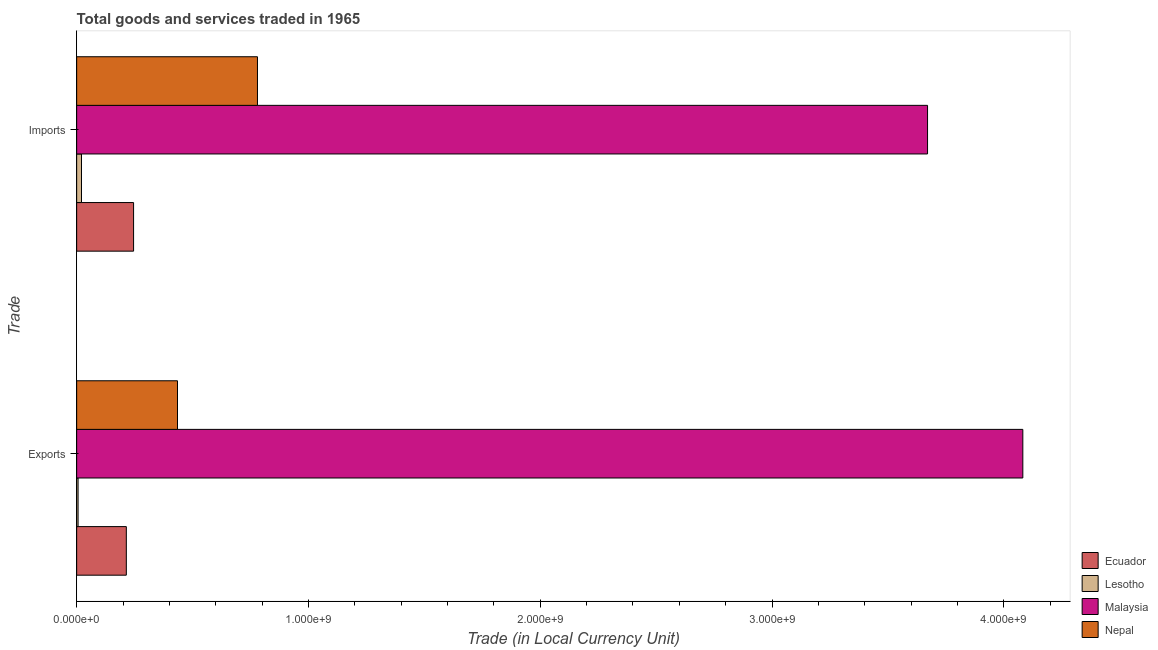How many different coloured bars are there?
Your answer should be very brief. 4. What is the label of the 1st group of bars from the top?
Offer a terse response. Imports. What is the imports of goods and services in Malaysia?
Offer a terse response. 3.67e+09. Across all countries, what is the maximum export of goods and services?
Offer a very short reply. 4.08e+09. Across all countries, what is the minimum export of goods and services?
Your response must be concise. 6.10e+06. In which country was the export of goods and services maximum?
Offer a very short reply. Malaysia. In which country was the export of goods and services minimum?
Provide a succinct answer. Lesotho. What is the total imports of goods and services in the graph?
Your answer should be very brief. 4.72e+09. What is the difference between the imports of goods and services in Malaysia and that in Lesotho?
Your answer should be compact. 3.65e+09. What is the difference between the imports of goods and services in Lesotho and the export of goods and services in Nepal?
Offer a terse response. -4.14e+08. What is the average imports of goods and services per country?
Keep it short and to the point. 1.18e+09. What is the difference between the export of goods and services and imports of goods and services in Nepal?
Give a very brief answer. -3.45e+08. In how many countries, is the imports of goods and services greater than 3800000000 LCU?
Make the answer very short. 0. What is the ratio of the export of goods and services in Nepal to that in Ecuador?
Ensure brevity in your answer.  2.03. Is the export of goods and services in Lesotho less than that in Ecuador?
Keep it short and to the point. Yes. What does the 4th bar from the top in Exports represents?
Offer a very short reply. Ecuador. What does the 1st bar from the bottom in Imports represents?
Offer a very short reply. Ecuador. How many bars are there?
Offer a terse response. 8. How many countries are there in the graph?
Keep it short and to the point. 4. What is the difference between two consecutive major ticks on the X-axis?
Provide a succinct answer. 1.00e+09. Are the values on the major ticks of X-axis written in scientific E-notation?
Offer a very short reply. Yes. Where does the legend appear in the graph?
Provide a succinct answer. Bottom right. How are the legend labels stacked?
Provide a short and direct response. Vertical. What is the title of the graph?
Your answer should be compact. Total goods and services traded in 1965. Does "Cayman Islands" appear as one of the legend labels in the graph?
Provide a succinct answer. No. What is the label or title of the X-axis?
Provide a short and direct response. Trade (in Local Currency Unit). What is the label or title of the Y-axis?
Your answer should be very brief. Trade. What is the Trade (in Local Currency Unit) in Ecuador in Exports?
Ensure brevity in your answer.  2.14e+08. What is the Trade (in Local Currency Unit) of Lesotho in Exports?
Make the answer very short. 6.10e+06. What is the Trade (in Local Currency Unit) in Malaysia in Exports?
Your response must be concise. 4.08e+09. What is the Trade (in Local Currency Unit) of Nepal in Exports?
Your answer should be compact. 4.35e+08. What is the Trade (in Local Currency Unit) of Ecuador in Imports?
Give a very brief answer. 2.46e+08. What is the Trade (in Local Currency Unit) in Lesotho in Imports?
Your answer should be very brief. 2.09e+07. What is the Trade (in Local Currency Unit) of Malaysia in Imports?
Offer a very short reply. 3.67e+09. What is the Trade (in Local Currency Unit) in Nepal in Imports?
Make the answer very short. 7.80e+08. Across all Trade, what is the maximum Trade (in Local Currency Unit) of Ecuador?
Make the answer very short. 2.46e+08. Across all Trade, what is the maximum Trade (in Local Currency Unit) of Lesotho?
Give a very brief answer. 2.09e+07. Across all Trade, what is the maximum Trade (in Local Currency Unit) in Malaysia?
Provide a succinct answer. 4.08e+09. Across all Trade, what is the maximum Trade (in Local Currency Unit) in Nepal?
Offer a terse response. 7.80e+08. Across all Trade, what is the minimum Trade (in Local Currency Unit) in Ecuador?
Provide a succinct answer. 2.14e+08. Across all Trade, what is the minimum Trade (in Local Currency Unit) in Lesotho?
Ensure brevity in your answer.  6.10e+06. Across all Trade, what is the minimum Trade (in Local Currency Unit) of Malaysia?
Your answer should be very brief. 3.67e+09. Across all Trade, what is the minimum Trade (in Local Currency Unit) in Nepal?
Provide a succinct answer. 4.35e+08. What is the total Trade (in Local Currency Unit) of Ecuador in the graph?
Ensure brevity in your answer.  4.60e+08. What is the total Trade (in Local Currency Unit) of Lesotho in the graph?
Offer a terse response. 2.70e+07. What is the total Trade (in Local Currency Unit) in Malaysia in the graph?
Provide a succinct answer. 7.75e+09. What is the total Trade (in Local Currency Unit) in Nepal in the graph?
Offer a very short reply. 1.22e+09. What is the difference between the Trade (in Local Currency Unit) in Ecuador in Exports and that in Imports?
Provide a succinct answer. -3.13e+07. What is the difference between the Trade (in Local Currency Unit) in Lesotho in Exports and that in Imports?
Offer a very short reply. -1.48e+07. What is the difference between the Trade (in Local Currency Unit) of Malaysia in Exports and that in Imports?
Offer a terse response. 4.11e+08. What is the difference between the Trade (in Local Currency Unit) of Nepal in Exports and that in Imports?
Give a very brief answer. -3.45e+08. What is the difference between the Trade (in Local Currency Unit) in Ecuador in Exports and the Trade (in Local Currency Unit) in Lesotho in Imports?
Make the answer very short. 1.93e+08. What is the difference between the Trade (in Local Currency Unit) in Ecuador in Exports and the Trade (in Local Currency Unit) in Malaysia in Imports?
Provide a succinct answer. -3.46e+09. What is the difference between the Trade (in Local Currency Unit) in Ecuador in Exports and the Trade (in Local Currency Unit) in Nepal in Imports?
Your response must be concise. -5.66e+08. What is the difference between the Trade (in Local Currency Unit) of Lesotho in Exports and the Trade (in Local Currency Unit) of Malaysia in Imports?
Offer a very short reply. -3.66e+09. What is the difference between the Trade (in Local Currency Unit) of Lesotho in Exports and the Trade (in Local Currency Unit) of Nepal in Imports?
Provide a short and direct response. -7.74e+08. What is the difference between the Trade (in Local Currency Unit) in Malaysia in Exports and the Trade (in Local Currency Unit) in Nepal in Imports?
Provide a short and direct response. 3.30e+09. What is the average Trade (in Local Currency Unit) of Ecuador per Trade?
Your answer should be compact. 2.30e+08. What is the average Trade (in Local Currency Unit) in Lesotho per Trade?
Your response must be concise. 1.35e+07. What is the average Trade (in Local Currency Unit) in Malaysia per Trade?
Keep it short and to the point. 3.88e+09. What is the average Trade (in Local Currency Unit) in Nepal per Trade?
Give a very brief answer. 6.08e+08. What is the difference between the Trade (in Local Currency Unit) of Ecuador and Trade (in Local Currency Unit) of Lesotho in Exports?
Your response must be concise. 2.08e+08. What is the difference between the Trade (in Local Currency Unit) of Ecuador and Trade (in Local Currency Unit) of Malaysia in Exports?
Your answer should be compact. -3.87e+09. What is the difference between the Trade (in Local Currency Unit) of Ecuador and Trade (in Local Currency Unit) of Nepal in Exports?
Ensure brevity in your answer.  -2.21e+08. What is the difference between the Trade (in Local Currency Unit) of Lesotho and Trade (in Local Currency Unit) of Malaysia in Exports?
Provide a short and direct response. -4.08e+09. What is the difference between the Trade (in Local Currency Unit) in Lesotho and Trade (in Local Currency Unit) in Nepal in Exports?
Offer a very short reply. -4.29e+08. What is the difference between the Trade (in Local Currency Unit) of Malaysia and Trade (in Local Currency Unit) of Nepal in Exports?
Your answer should be compact. 3.65e+09. What is the difference between the Trade (in Local Currency Unit) in Ecuador and Trade (in Local Currency Unit) in Lesotho in Imports?
Provide a succinct answer. 2.25e+08. What is the difference between the Trade (in Local Currency Unit) of Ecuador and Trade (in Local Currency Unit) of Malaysia in Imports?
Give a very brief answer. -3.43e+09. What is the difference between the Trade (in Local Currency Unit) of Ecuador and Trade (in Local Currency Unit) of Nepal in Imports?
Your response must be concise. -5.34e+08. What is the difference between the Trade (in Local Currency Unit) in Lesotho and Trade (in Local Currency Unit) in Malaysia in Imports?
Your answer should be compact. -3.65e+09. What is the difference between the Trade (in Local Currency Unit) of Lesotho and Trade (in Local Currency Unit) of Nepal in Imports?
Provide a succinct answer. -7.59e+08. What is the difference between the Trade (in Local Currency Unit) of Malaysia and Trade (in Local Currency Unit) of Nepal in Imports?
Provide a succinct answer. 2.89e+09. What is the ratio of the Trade (in Local Currency Unit) in Ecuador in Exports to that in Imports?
Offer a very short reply. 0.87. What is the ratio of the Trade (in Local Currency Unit) in Lesotho in Exports to that in Imports?
Provide a succinct answer. 0.29. What is the ratio of the Trade (in Local Currency Unit) of Malaysia in Exports to that in Imports?
Provide a short and direct response. 1.11. What is the ratio of the Trade (in Local Currency Unit) in Nepal in Exports to that in Imports?
Provide a succinct answer. 0.56. What is the difference between the highest and the second highest Trade (in Local Currency Unit) in Ecuador?
Offer a terse response. 3.13e+07. What is the difference between the highest and the second highest Trade (in Local Currency Unit) of Lesotho?
Provide a succinct answer. 1.48e+07. What is the difference between the highest and the second highest Trade (in Local Currency Unit) in Malaysia?
Your answer should be compact. 4.11e+08. What is the difference between the highest and the second highest Trade (in Local Currency Unit) of Nepal?
Your answer should be compact. 3.45e+08. What is the difference between the highest and the lowest Trade (in Local Currency Unit) in Ecuador?
Your response must be concise. 3.13e+07. What is the difference between the highest and the lowest Trade (in Local Currency Unit) of Lesotho?
Keep it short and to the point. 1.48e+07. What is the difference between the highest and the lowest Trade (in Local Currency Unit) in Malaysia?
Offer a very short reply. 4.11e+08. What is the difference between the highest and the lowest Trade (in Local Currency Unit) in Nepal?
Your answer should be compact. 3.45e+08. 